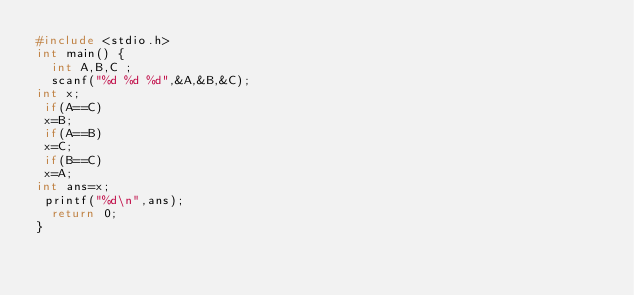<code> <loc_0><loc_0><loc_500><loc_500><_C_>#include <stdio.h>
int main() {
  int A,B,C ;
  scanf("%d %d %d",&A,&B,&C);
int x;
 if(A==C)
 x=B;
 if(A==B)
 x=C;
 if(B==C)
 x=A;
int ans=x;
 printf("%d\n",ans);
  return 0;
}</code> 